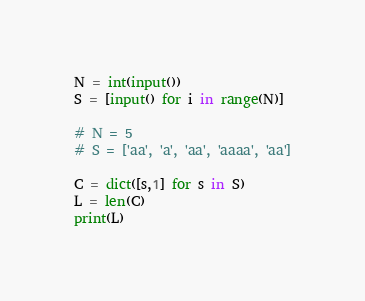<code> <loc_0><loc_0><loc_500><loc_500><_Python_>N = int(input())
S = [input() for i in range(N)]

# N = 5
# S = ['aa', 'a', 'aa', 'aaaa', 'aa']

C = dict([s,1] for s in S)
L = len(C)
print(L)</code> 